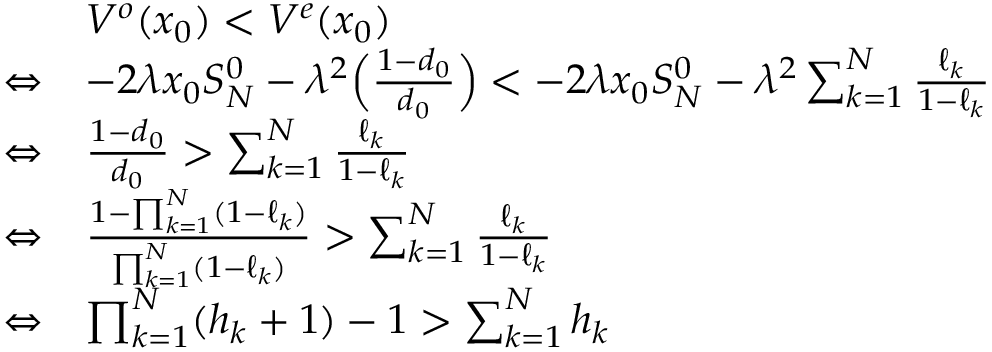<formula> <loc_0><loc_0><loc_500><loc_500>\begin{array} { r l } & { V ^ { o } ( x _ { 0 } ) < V ^ { e } ( x _ { 0 } ) } \\ { \Leftrightarrow } & { - 2 \lambda x _ { 0 } S _ { N } ^ { 0 } - \lambda ^ { 2 } \left ( \frac { 1 - d _ { 0 } } { d _ { 0 } } \right ) < - 2 \lambda x _ { 0 } S _ { N } ^ { 0 } - \lambda ^ { 2 } \sum _ { k = 1 } ^ { N } \frac { \ell _ { k } } { 1 - \ell _ { k } } } \\ { \Leftrightarrow } & { \frac { 1 - d _ { 0 } } { d _ { 0 } } > \sum _ { k = 1 } ^ { N } \frac { \ell _ { k } } { 1 - \ell _ { k } } } \\ { \Leftrightarrow } & { \frac { 1 - \prod _ { k = 1 } ^ { N } ( 1 - \ell _ { k } ) } { \prod _ { k = 1 } ^ { N } ( 1 - \ell _ { k } ) } > \sum _ { k = 1 } ^ { N } \frac { \ell _ { k } } { 1 - \ell _ { k } } } \\ { \Leftrightarrow } & { \prod _ { k = 1 } ^ { N } ( h _ { k } + 1 ) - 1 > \sum _ { k = 1 } ^ { N } h _ { k } } \end{array}</formula> 